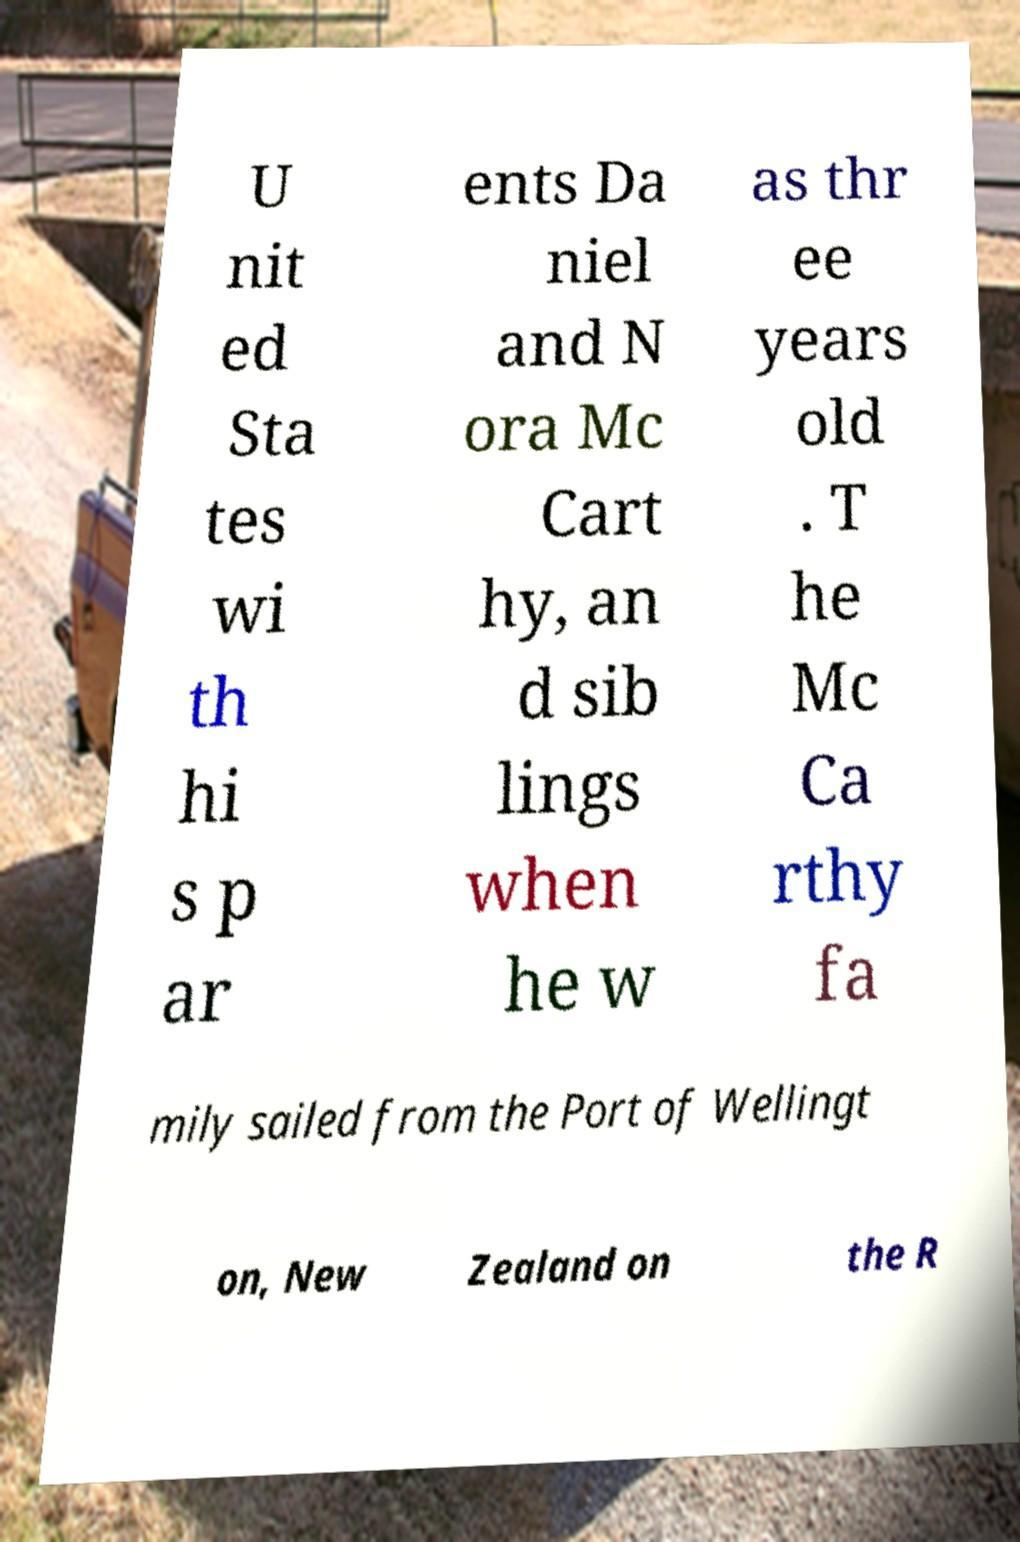I need the written content from this picture converted into text. Can you do that? U nit ed Sta tes wi th hi s p ar ents Da niel and N ora Mc Cart hy, an d sib lings when he w as thr ee years old . T he Mc Ca rthy fa mily sailed from the Port of Wellingt on, New Zealand on the R 